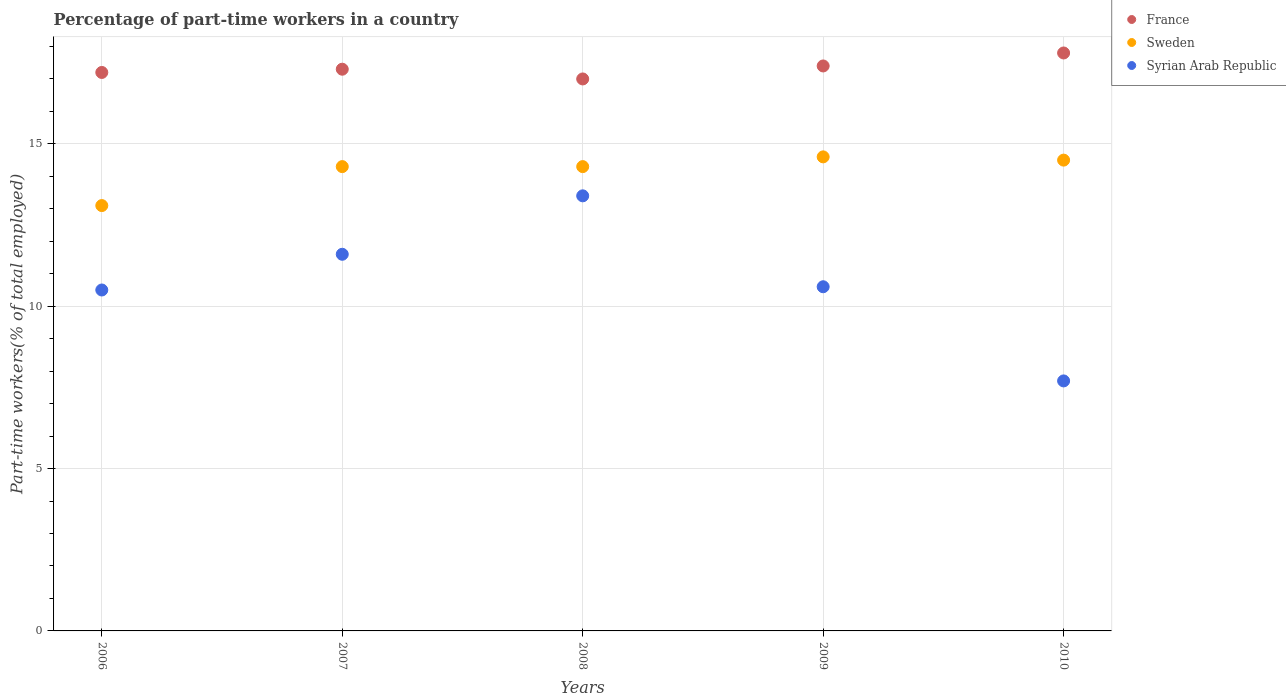How many different coloured dotlines are there?
Offer a terse response. 3. Is the number of dotlines equal to the number of legend labels?
Your answer should be very brief. Yes. What is the percentage of part-time workers in Syrian Arab Republic in 2007?
Offer a very short reply. 11.6. Across all years, what is the maximum percentage of part-time workers in Sweden?
Your answer should be compact. 14.6. Across all years, what is the minimum percentage of part-time workers in Syrian Arab Republic?
Make the answer very short. 7.7. In which year was the percentage of part-time workers in Syrian Arab Republic maximum?
Your answer should be very brief. 2008. In which year was the percentage of part-time workers in France minimum?
Your answer should be compact. 2008. What is the total percentage of part-time workers in Syrian Arab Republic in the graph?
Your response must be concise. 53.8. What is the difference between the percentage of part-time workers in Sweden in 2006 and that in 2010?
Offer a very short reply. -1.4. What is the difference between the percentage of part-time workers in France in 2009 and the percentage of part-time workers in Sweden in 2007?
Offer a very short reply. 3.1. What is the average percentage of part-time workers in Syrian Arab Republic per year?
Ensure brevity in your answer.  10.76. In the year 2009, what is the difference between the percentage of part-time workers in Syrian Arab Republic and percentage of part-time workers in Sweden?
Keep it short and to the point. -4. What is the ratio of the percentage of part-time workers in France in 2007 to that in 2010?
Your answer should be compact. 0.97. Is the percentage of part-time workers in Sweden in 2006 less than that in 2010?
Provide a succinct answer. Yes. What is the difference between the highest and the second highest percentage of part-time workers in Syrian Arab Republic?
Ensure brevity in your answer.  1.8. What is the difference between the highest and the lowest percentage of part-time workers in Syrian Arab Republic?
Offer a very short reply. 5.7. In how many years, is the percentage of part-time workers in Sweden greater than the average percentage of part-time workers in Sweden taken over all years?
Make the answer very short. 4. Is it the case that in every year, the sum of the percentage of part-time workers in Syrian Arab Republic and percentage of part-time workers in Sweden  is greater than the percentage of part-time workers in France?
Give a very brief answer. Yes. Is the percentage of part-time workers in Syrian Arab Republic strictly greater than the percentage of part-time workers in France over the years?
Offer a terse response. No. How many dotlines are there?
Your answer should be very brief. 3. How many years are there in the graph?
Your answer should be very brief. 5. Does the graph contain any zero values?
Make the answer very short. No. Where does the legend appear in the graph?
Give a very brief answer. Top right. How are the legend labels stacked?
Keep it short and to the point. Vertical. What is the title of the graph?
Your response must be concise. Percentage of part-time workers in a country. Does "High income: nonOECD" appear as one of the legend labels in the graph?
Your answer should be compact. No. What is the label or title of the Y-axis?
Ensure brevity in your answer.  Part-time workers(% of total employed). What is the Part-time workers(% of total employed) in France in 2006?
Your response must be concise. 17.2. What is the Part-time workers(% of total employed) in Sweden in 2006?
Offer a very short reply. 13.1. What is the Part-time workers(% of total employed) of Syrian Arab Republic in 2006?
Give a very brief answer. 10.5. What is the Part-time workers(% of total employed) of France in 2007?
Give a very brief answer. 17.3. What is the Part-time workers(% of total employed) in Sweden in 2007?
Offer a very short reply. 14.3. What is the Part-time workers(% of total employed) of Syrian Arab Republic in 2007?
Offer a terse response. 11.6. What is the Part-time workers(% of total employed) of Sweden in 2008?
Your answer should be compact. 14.3. What is the Part-time workers(% of total employed) in Syrian Arab Republic in 2008?
Your response must be concise. 13.4. What is the Part-time workers(% of total employed) in France in 2009?
Your answer should be compact. 17.4. What is the Part-time workers(% of total employed) of Sweden in 2009?
Offer a very short reply. 14.6. What is the Part-time workers(% of total employed) of Syrian Arab Republic in 2009?
Make the answer very short. 10.6. What is the Part-time workers(% of total employed) in France in 2010?
Offer a very short reply. 17.8. What is the Part-time workers(% of total employed) in Sweden in 2010?
Offer a very short reply. 14.5. What is the Part-time workers(% of total employed) in Syrian Arab Republic in 2010?
Your response must be concise. 7.7. Across all years, what is the maximum Part-time workers(% of total employed) of France?
Provide a succinct answer. 17.8. Across all years, what is the maximum Part-time workers(% of total employed) in Sweden?
Give a very brief answer. 14.6. Across all years, what is the maximum Part-time workers(% of total employed) in Syrian Arab Republic?
Offer a very short reply. 13.4. Across all years, what is the minimum Part-time workers(% of total employed) in France?
Ensure brevity in your answer.  17. Across all years, what is the minimum Part-time workers(% of total employed) in Sweden?
Your response must be concise. 13.1. Across all years, what is the minimum Part-time workers(% of total employed) of Syrian Arab Republic?
Offer a terse response. 7.7. What is the total Part-time workers(% of total employed) of France in the graph?
Your answer should be very brief. 86.7. What is the total Part-time workers(% of total employed) of Sweden in the graph?
Your response must be concise. 70.8. What is the total Part-time workers(% of total employed) of Syrian Arab Republic in the graph?
Offer a terse response. 53.8. What is the difference between the Part-time workers(% of total employed) of France in 2006 and that in 2007?
Provide a succinct answer. -0.1. What is the difference between the Part-time workers(% of total employed) in Syrian Arab Republic in 2006 and that in 2008?
Make the answer very short. -2.9. What is the difference between the Part-time workers(% of total employed) in Sweden in 2006 and that in 2009?
Provide a succinct answer. -1.5. What is the difference between the Part-time workers(% of total employed) in Syrian Arab Republic in 2006 and that in 2009?
Keep it short and to the point. -0.1. What is the difference between the Part-time workers(% of total employed) of France in 2006 and that in 2010?
Keep it short and to the point. -0.6. What is the difference between the Part-time workers(% of total employed) in Syrian Arab Republic in 2007 and that in 2008?
Offer a very short reply. -1.8. What is the difference between the Part-time workers(% of total employed) of France in 2007 and that in 2009?
Your answer should be compact. -0.1. What is the difference between the Part-time workers(% of total employed) in Sweden in 2007 and that in 2009?
Offer a terse response. -0.3. What is the difference between the Part-time workers(% of total employed) in Syrian Arab Republic in 2007 and that in 2009?
Your answer should be very brief. 1. What is the difference between the Part-time workers(% of total employed) in Sweden in 2007 and that in 2010?
Your answer should be compact. -0.2. What is the difference between the Part-time workers(% of total employed) in Syrian Arab Republic in 2007 and that in 2010?
Ensure brevity in your answer.  3.9. What is the difference between the Part-time workers(% of total employed) in France in 2008 and that in 2009?
Your answer should be compact. -0.4. What is the difference between the Part-time workers(% of total employed) in France in 2008 and that in 2010?
Give a very brief answer. -0.8. What is the difference between the Part-time workers(% of total employed) in Syrian Arab Republic in 2009 and that in 2010?
Offer a very short reply. 2.9. What is the difference between the Part-time workers(% of total employed) of France in 2006 and the Part-time workers(% of total employed) of Syrian Arab Republic in 2007?
Provide a short and direct response. 5.6. What is the difference between the Part-time workers(% of total employed) of France in 2006 and the Part-time workers(% of total employed) of Syrian Arab Republic in 2009?
Make the answer very short. 6.6. What is the difference between the Part-time workers(% of total employed) of France in 2006 and the Part-time workers(% of total employed) of Sweden in 2010?
Your response must be concise. 2.7. What is the difference between the Part-time workers(% of total employed) in France in 2006 and the Part-time workers(% of total employed) in Syrian Arab Republic in 2010?
Make the answer very short. 9.5. What is the difference between the Part-time workers(% of total employed) of France in 2007 and the Part-time workers(% of total employed) of Syrian Arab Republic in 2008?
Your answer should be compact. 3.9. What is the difference between the Part-time workers(% of total employed) of Sweden in 2007 and the Part-time workers(% of total employed) of Syrian Arab Republic in 2008?
Keep it short and to the point. 0.9. What is the difference between the Part-time workers(% of total employed) in France in 2007 and the Part-time workers(% of total employed) in Sweden in 2009?
Your answer should be compact. 2.7. What is the difference between the Part-time workers(% of total employed) of Sweden in 2007 and the Part-time workers(% of total employed) of Syrian Arab Republic in 2009?
Your response must be concise. 3.7. What is the difference between the Part-time workers(% of total employed) in France in 2008 and the Part-time workers(% of total employed) in Sweden in 2009?
Your answer should be compact. 2.4. What is the difference between the Part-time workers(% of total employed) of France in 2008 and the Part-time workers(% of total employed) of Sweden in 2010?
Your answer should be compact. 2.5. What is the difference between the Part-time workers(% of total employed) in France in 2009 and the Part-time workers(% of total employed) in Sweden in 2010?
Your response must be concise. 2.9. What is the difference between the Part-time workers(% of total employed) in France in 2009 and the Part-time workers(% of total employed) in Syrian Arab Republic in 2010?
Your answer should be compact. 9.7. What is the difference between the Part-time workers(% of total employed) of Sweden in 2009 and the Part-time workers(% of total employed) of Syrian Arab Republic in 2010?
Your answer should be compact. 6.9. What is the average Part-time workers(% of total employed) in France per year?
Keep it short and to the point. 17.34. What is the average Part-time workers(% of total employed) in Sweden per year?
Provide a succinct answer. 14.16. What is the average Part-time workers(% of total employed) of Syrian Arab Republic per year?
Your response must be concise. 10.76. In the year 2007, what is the difference between the Part-time workers(% of total employed) of France and Part-time workers(% of total employed) of Syrian Arab Republic?
Your answer should be very brief. 5.7. In the year 2007, what is the difference between the Part-time workers(% of total employed) of Sweden and Part-time workers(% of total employed) of Syrian Arab Republic?
Ensure brevity in your answer.  2.7. In the year 2008, what is the difference between the Part-time workers(% of total employed) of Sweden and Part-time workers(% of total employed) of Syrian Arab Republic?
Provide a short and direct response. 0.9. In the year 2009, what is the difference between the Part-time workers(% of total employed) in France and Part-time workers(% of total employed) in Syrian Arab Republic?
Your answer should be very brief. 6.8. In the year 2010, what is the difference between the Part-time workers(% of total employed) of France and Part-time workers(% of total employed) of Sweden?
Offer a very short reply. 3.3. In the year 2010, what is the difference between the Part-time workers(% of total employed) of France and Part-time workers(% of total employed) of Syrian Arab Republic?
Provide a short and direct response. 10.1. What is the ratio of the Part-time workers(% of total employed) of France in 2006 to that in 2007?
Make the answer very short. 0.99. What is the ratio of the Part-time workers(% of total employed) of Sweden in 2006 to that in 2007?
Your answer should be very brief. 0.92. What is the ratio of the Part-time workers(% of total employed) of Syrian Arab Republic in 2006 to that in 2007?
Make the answer very short. 0.91. What is the ratio of the Part-time workers(% of total employed) in France in 2006 to that in 2008?
Offer a very short reply. 1.01. What is the ratio of the Part-time workers(% of total employed) of Sweden in 2006 to that in 2008?
Provide a short and direct response. 0.92. What is the ratio of the Part-time workers(% of total employed) of Syrian Arab Republic in 2006 to that in 2008?
Ensure brevity in your answer.  0.78. What is the ratio of the Part-time workers(% of total employed) in France in 2006 to that in 2009?
Ensure brevity in your answer.  0.99. What is the ratio of the Part-time workers(% of total employed) of Sweden in 2006 to that in 2009?
Provide a succinct answer. 0.9. What is the ratio of the Part-time workers(% of total employed) of Syrian Arab Republic in 2006 to that in 2009?
Make the answer very short. 0.99. What is the ratio of the Part-time workers(% of total employed) of France in 2006 to that in 2010?
Your answer should be compact. 0.97. What is the ratio of the Part-time workers(% of total employed) of Sweden in 2006 to that in 2010?
Your answer should be compact. 0.9. What is the ratio of the Part-time workers(% of total employed) of Syrian Arab Republic in 2006 to that in 2010?
Your answer should be compact. 1.36. What is the ratio of the Part-time workers(% of total employed) of France in 2007 to that in 2008?
Your answer should be compact. 1.02. What is the ratio of the Part-time workers(% of total employed) of Sweden in 2007 to that in 2008?
Keep it short and to the point. 1. What is the ratio of the Part-time workers(% of total employed) of Syrian Arab Republic in 2007 to that in 2008?
Offer a very short reply. 0.87. What is the ratio of the Part-time workers(% of total employed) in France in 2007 to that in 2009?
Keep it short and to the point. 0.99. What is the ratio of the Part-time workers(% of total employed) in Sweden in 2007 to that in 2009?
Offer a terse response. 0.98. What is the ratio of the Part-time workers(% of total employed) in Syrian Arab Republic in 2007 to that in 2009?
Provide a short and direct response. 1.09. What is the ratio of the Part-time workers(% of total employed) in France in 2007 to that in 2010?
Provide a short and direct response. 0.97. What is the ratio of the Part-time workers(% of total employed) of Sweden in 2007 to that in 2010?
Your answer should be very brief. 0.99. What is the ratio of the Part-time workers(% of total employed) in Syrian Arab Republic in 2007 to that in 2010?
Your response must be concise. 1.51. What is the ratio of the Part-time workers(% of total employed) of Sweden in 2008 to that in 2009?
Give a very brief answer. 0.98. What is the ratio of the Part-time workers(% of total employed) in Syrian Arab Republic in 2008 to that in 2009?
Provide a short and direct response. 1.26. What is the ratio of the Part-time workers(% of total employed) in France in 2008 to that in 2010?
Your response must be concise. 0.96. What is the ratio of the Part-time workers(% of total employed) in Sweden in 2008 to that in 2010?
Your answer should be very brief. 0.99. What is the ratio of the Part-time workers(% of total employed) in Syrian Arab Republic in 2008 to that in 2010?
Your answer should be very brief. 1.74. What is the ratio of the Part-time workers(% of total employed) of France in 2009 to that in 2010?
Provide a short and direct response. 0.98. What is the ratio of the Part-time workers(% of total employed) in Sweden in 2009 to that in 2010?
Offer a very short reply. 1.01. What is the ratio of the Part-time workers(% of total employed) in Syrian Arab Republic in 2009 to that in 2010?
Your response must be concise. 1.38. What is the difference between the highest and the lowest Part-time workers(% of total employed) in France?
Offer a terse response. 0.8. What is the difference between the highest and the lowest Part-time workers(% of total employed) of Sweden?
Keep it short and to the point. 1.5. 